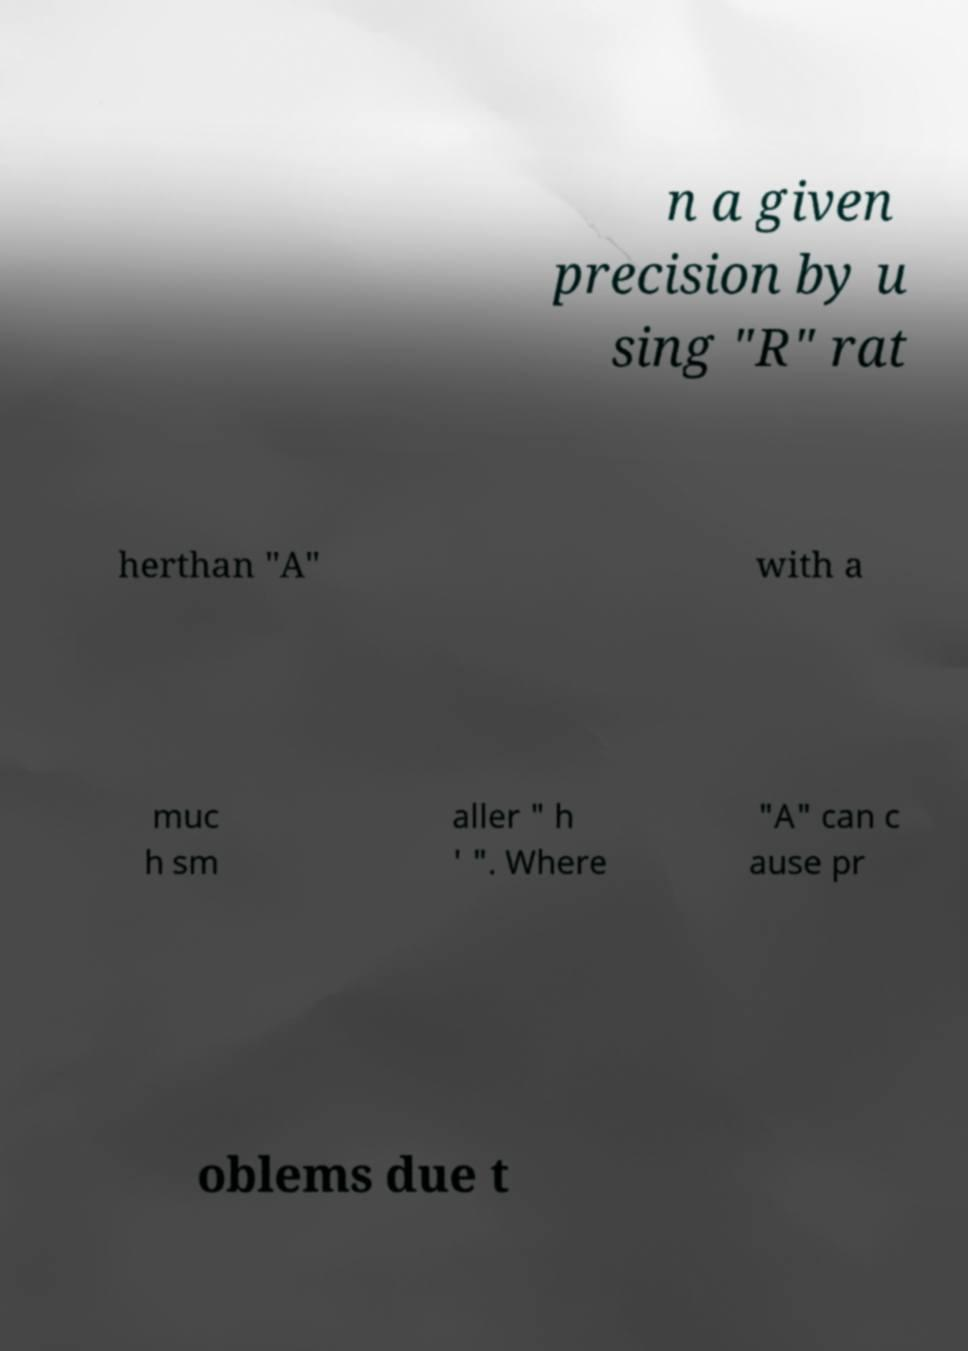Can you accurately transcribe the text from the provided image for me? n a given precision by u sing "R" rat herthan "A" with a muc h sm aller " h ' ". Where "A" can c ause pr oblems due t 